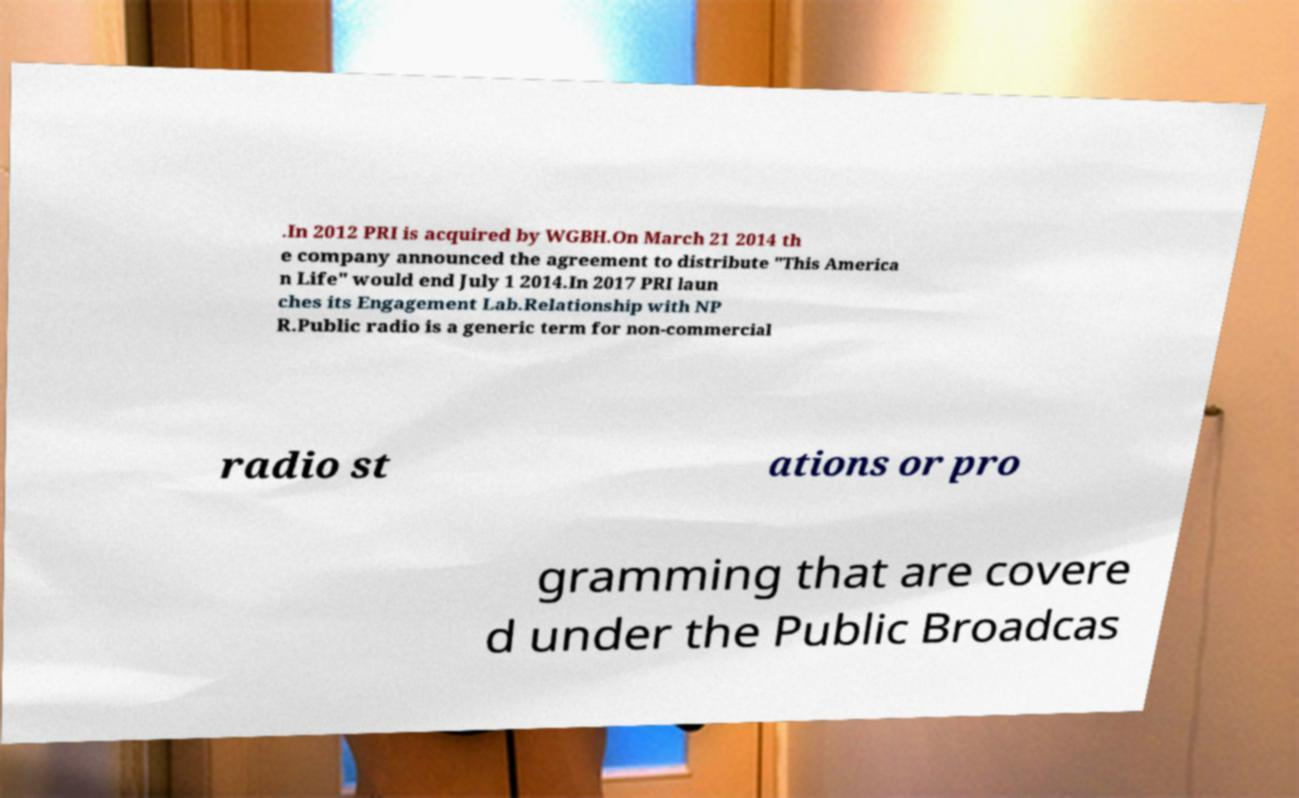Could you assist in decoding the text presented in this image and type it out clearly? .In 2012 PRI is acquired by WGBH.On March 21 2014 th e company announced the agreement to distribute "This America n Life" would end July 1 2014.In 2017 PRI laun ches its Engagement Lab.Relationship with NP R.Public radio is a generic term for non-commercial radio st ations or pro gramming that are covere d under the Public Broadcas 